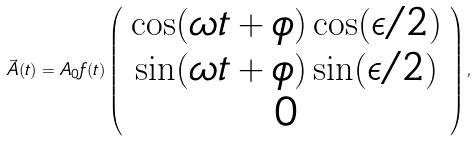Convert formula to latex. <formula><loc_0><loc_0><loc_500><loc_500>\vec { A } ( t ) = A _ { 0 } f ( t ) \left ( \begin{array} { c } \cos ( \omega t + \phi ) \cos ( \epsilon / 2 ) \\ \sin ( \omega t + \phi ) \sin ( \epsilon / 2 ) \\ 0 \end{array} \right ) ,</formula> 